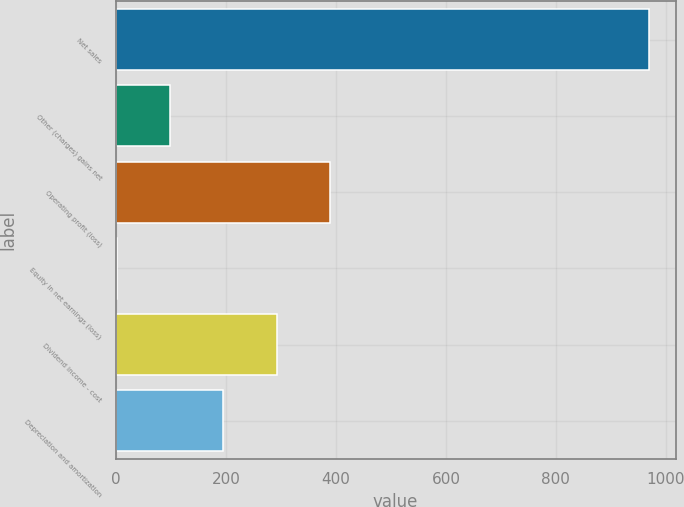<chart> <loc_0><loc_0><loc_500><loc_500><bar_chart><fcel>Net sales<fcel>Other (charges) gains net<fcel>Operating profit (loss)<fcel>Equity in net earnings (loss)<fcel>Dividend income - cost<fcel>Depreciation and amortization<nl><fcel>969<fcel>98.7<fcel>388.8<fcel>2<fcel>292.1<fcel>195.4<nl></chart> 